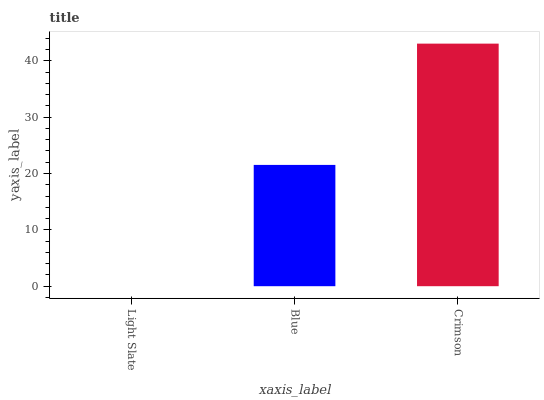Is Light Slate the minimum?
Answer yes or no. Yes. Is Crimson the maximum?
Answer yes or no. Yes. Is Blue the minimum?
Answer yes or no. No. Is Blue the maximum?
Answer yes or no. No. Is Blue greater than Light Slate?
Answer yes or no. Yes. Is Light Slate less than Blue?
Answer yes or no. Yes. Is Light Slate greater than Blue?
Answer yes or no. No. Is Blue less than Light Slate?
Answer yes or no. No. Is Blue the high median?
Answer yes or no. Yes. Is Blue the low median?
Answer yes or no. Yes. Is Crimson the high median?
Answer yes or no. No. Is Light Slate the low median?
Answer yes or no. No. 